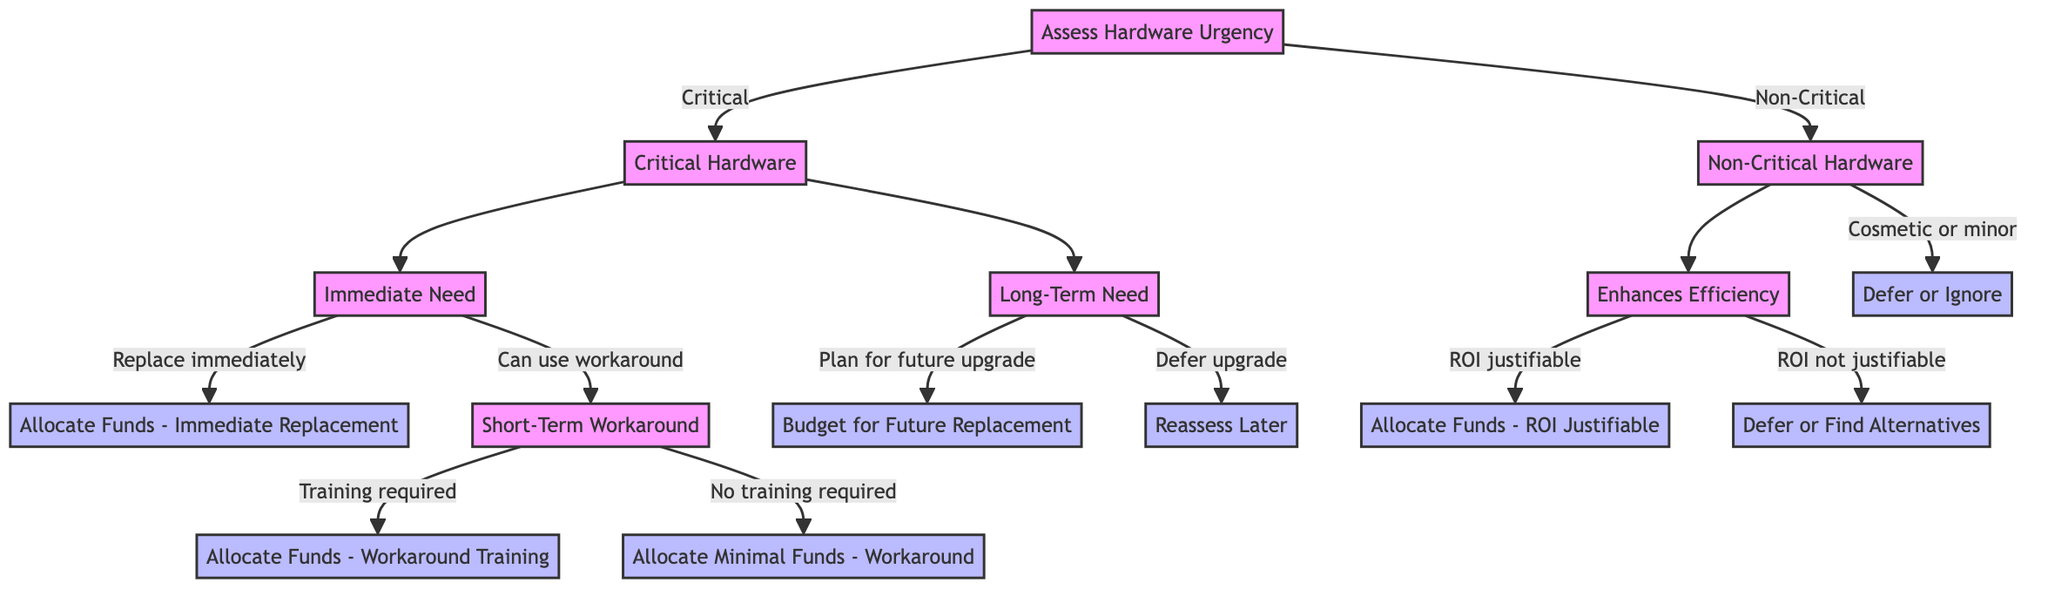What is the first decision in the diagram? The first decision node is "Assess Hardware Urgency". It sets the stage for determining whether the hardware is critical or non-critical.
Answer: Assess Hardware Urgency How many branches does the "Critical Hardware" node have? The "Critical Hardware" node has two branches: "Immediate need" and "Long-term need".
Answer: Two branches What action follows if the decision is "Immediate need" and the option is "Replace immediately"? The action that follows is "Allocate funds to replace immediately", which indicates immediate allocation of funds for replacement.
Answer: Allocate Funds - Immediate Replacement What happens if the decision at the "Non-Critical Hardware" node is "Cosmetic or minor"? If the decision is "Cosmetic or minor", the resulting action is "Defer or Ignore", implying that no immediate action is necessary.
Answer: Defer or Ignore If the need is "Enhances efficiency" and "ROI not justifiable", what decision does the manager make? The manager would choose "Defer upgrade or find alternative solutions", indicating that the upgrade won't be pursued at this time.
Answer: Defer or Find Alternatives What is the action taken if "Short-term workaround" requires "Training required"? The action taken is "Allocate funds for training to implement the workaround", which focuses on providing resources for necessary training.
Answer: Allocate Funds - Workaround Training In total, how many actions are listed in the diagram? There are seven unique action nodes in the decision tree diagram. This includes both funding allocations and planning actions.
Answer: Seven actions What decision follows if the "Critical Hardware" is deemed a "Long-term need"? The subsequent decision is to "Plan for future upgrade", reflecting a proactive approach to budget and schedule upcoming needs.
Answer: Plan for future upgrade 